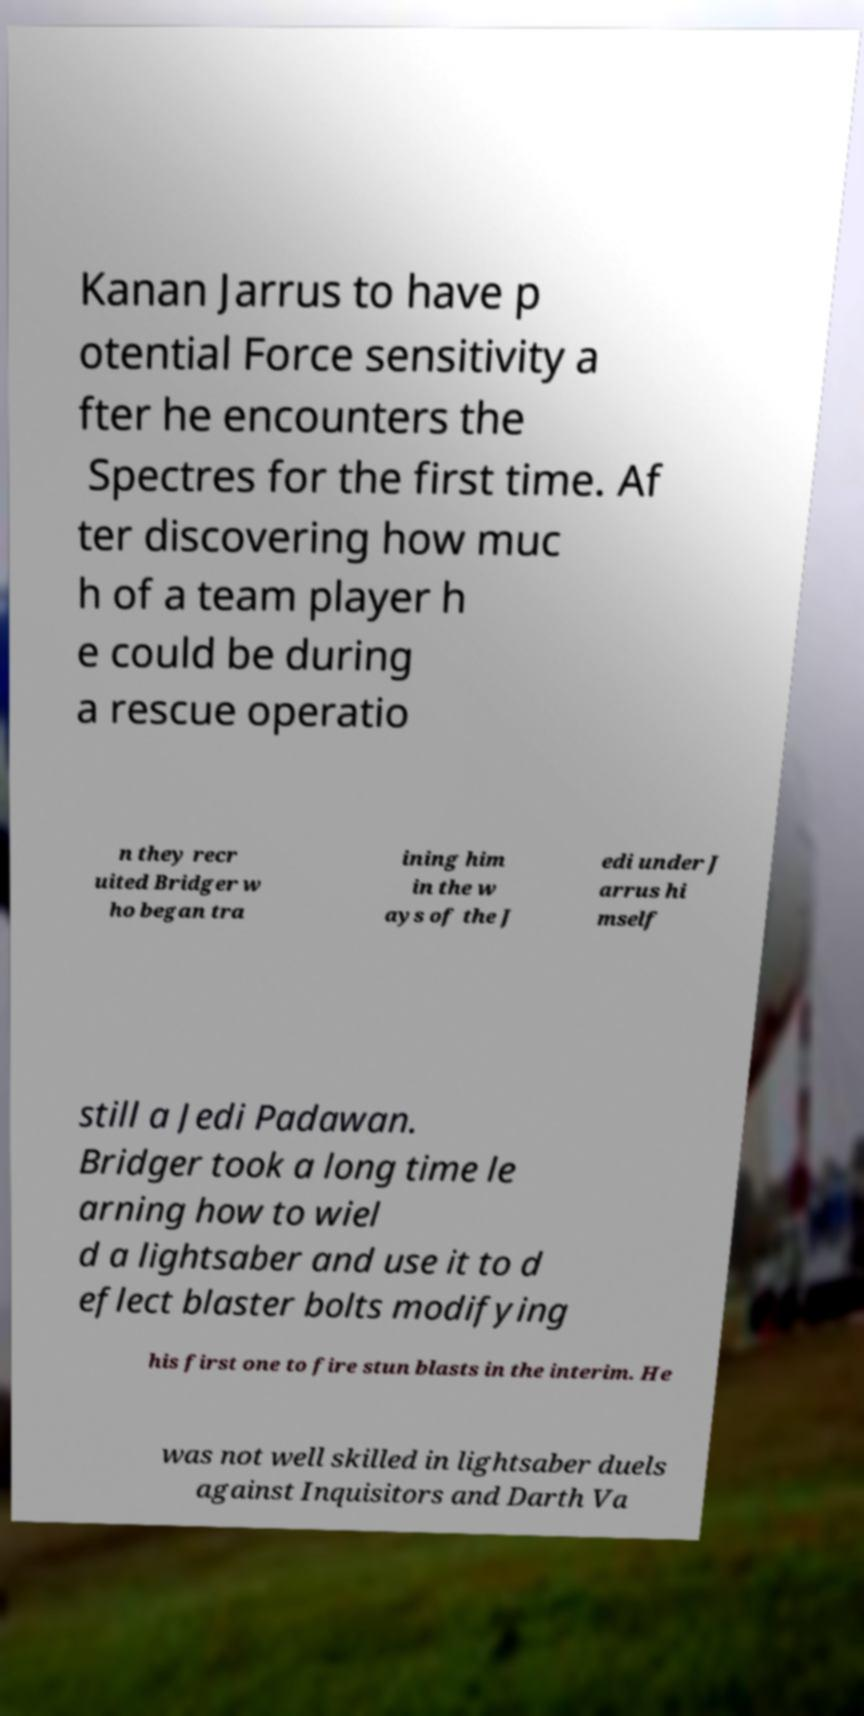Can you accurately transcribe the text from the provided image for me? Kanan Jarrus to have p otential Force sensitivity a fter he encounters the Spectres for the first time. Af ter discovering how muc h of a team player h e could be during a rescue operatio n they recr uited Bridger w ho began tra ining him in the w ays of the J edi under J arrus hi mself still a Jedi Padawan. Bridger took a long time le arning how to wiel d a lightsaber and use it to d eflect blaster bolts modifying his first one to fire stun blasts in the interim. He was not well skilled in lightsaber duels against Inquisitors and Darth Va 